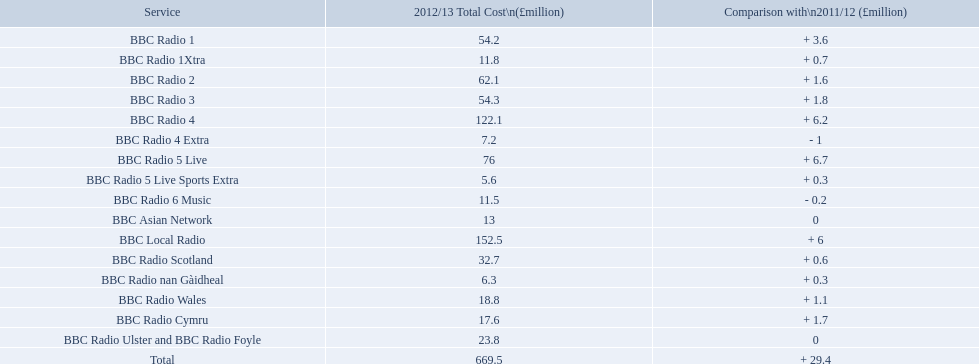What are the bbc stations? BBC Radio 1, BBC Radio 1Xtra, BBC Radio 2, BBC Radio 3, BBC Radio 4, BBC Radio 4 Extra, BBC Radio 5 Live, BBC Radio 5 Live Sports Extra, BBC Radio 6 Music, BBC Asian Network, BBC Local Radio, BBC Radio Scotland, BBC Radio nan Gàidheal, BBC Radio Wales, BBC Radio Cymru, BBC Radio Ulster and BBC Radio Foyle. What was the highest cost to run out of all? 122.1. Which one cost this? BBC Local Radio. What are the bbc outlets? BBC Radio 1, BBC Radio 1Xtra, BBC Radio 2, BBC Radio 3, BBC Radio 4, BBC Radio 4 Extra, BBC Radio 5 Live, BBC Radio 5 Live Sports Extra, BBC Radio 6 Music, BBC Asian Network, BBC Local Radio, BBC Radio Scotland, BBC Radio nan Gàidheal, BBC Radio Wales, BBC Radio Cymru, BBC Radio Ulster and BBC Radio Foyle. What was the top cost to manage among all? 122.1. Which one incurred this? BBC Local Radio. What are the bbc channels? BBC Radio 1, BBC Radio 1Xtra, BBC Radio 2, BBC Radio 3, BBC Radio 4, BBC Radio 4 Extra, BBC Radio 5 Live, BBC Radio 5 Live Sports Extra, BBC Radio 6 Music, BBC Asian Network, BBC Local Radio, BBC Radio Scotland, BBC Radio nan Gàidheal, BBC Radio Wales, BBC Radio Cymru, BBC Radio Ulster and BBC Radio Foyle. What had the greatest expense to operate among all? 122.1. Which one had this cost? BBC Local Radio. 